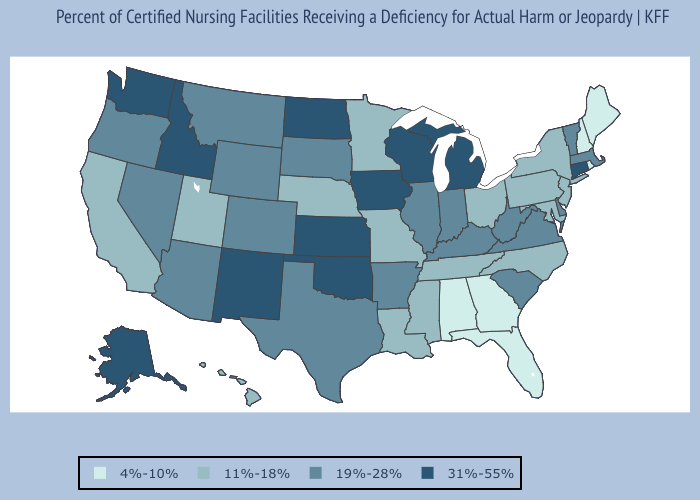Among the states that border Colorado , which have the lowest value?
Give a very brief answer. Nebraska, Utah. Name the states that have a value in the range 4%-10%?
Give a very brief answer. Alabama, Florida, Georgia, Maine, New Hampshire, Rhode Island. Which states have the lowest value in the Northeast?
Short answer required. Maine, New Hampshire, Rhode Island. Does Georgia have a lower value than New Hampshire?
Be succinct. No. Name the states that have a value in the range 4%-10%?
Give a very brief answer. Alabama, Florida, Georgia, Maine, New Hampshire, Rhode Island. What is the value of Maine?
Keep it brief. 4%-10%. Name the states that have a value in the range 31%-55%?
Keep it brief. Alaska, Connecticut, Idaho, Iowa, Kansas, Michigan, New Mexico, North Dakota, Oklahoma, Washington, Wisconsin. What is the highest value in the South ?
Quick response, please. 31%-55%. Does North Dakota have the highest value in the USA?
Answer briefly. Yes. Does Ohio have the highest value in the USA?
Short answer required. No. Name the states that have a value in the range 11%-18%?
Answer briefly. California, Hawaii, Louisiana, Maryland, Minnesota, Mississippi, Missouri, Nebraska, New Jersey, New York, North Carolina, Ohio, Pennsylvania, Tennessee, Utah. Name the states that have a value in the range 19%-28%?
Concise answer only. Arizona, Arkansas, Colorado, Delaware, Illinois, Indiana, Kentucky, Massachusetts, Montana, Nevada, Oregon, South Carolina, South Dakota, Texas, Vermont, Virginia, West Virginia, Wyoming. What is the lowest value in states that border Kansas?
Short answer required. 11%-18%. Name the states that have a value in the range 19%-28%?
Give a very brief answer. Arizona, Arkansas, Colorado, Delaware, Illinois, Indiana, Kentucky, Massachusetts, Montana, Nevada, Oregon, South Carolina, South Dakota, Texas, Vermont, Virginia, West Virginia, Wyoming. What is the value of Oklahoma?
Concise answer only. 31%-55%. 